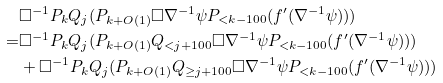<formula> <loc_0><loc_0><loc_500><loc_500>& \Box ^ { - 1 } P _ { k } Q _ { j } ( P _ { k + O ( 1 ) } \Box \nabla ^ { - 1 } \psi P _ { < k - 1 0 0 } ( f ^ { \prime } ( \nabla ^ { - 1 } \psi ) ) ) \\ = & \Box ^ { - 1 } P _ { k } Q _ { j } ( P _ { k + O ( 1 ) } Q _ { < j + 1 0 0 } \Box \nabla ^ { - 1 } \psi P _ { < k - 1 0 0 } ( f ^ { \prime } ( \nabla ^ { - 1 } \psi ) ) ) \\ & + \Box ^ { - 1 } P _ { k } Q _ { j } ( P _ { k + O ( 1 ) } Q _ { \geq j + 1 0 0 } \Box \nabla ^ { - 1 } \psi P _ { < k - 1 0 0 } ( f ^ { \prime } ( \nabla ^ { - 1 } \psi ) ) ) \\</formula> 